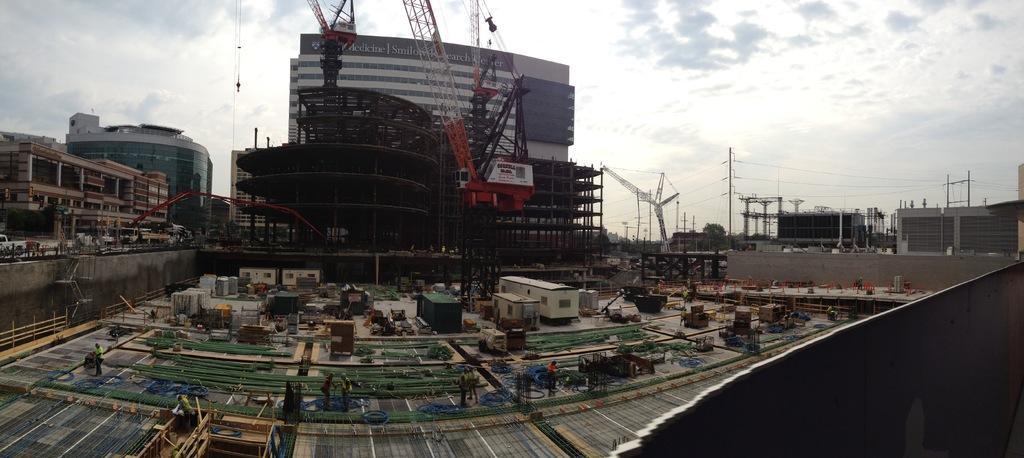Could you give a brief overview of what you see in this image? In the center of the image there are buildings and we can see a crane. At the bottom there are people doing construction work and we can see blocks and sheds. In the background there are poles, wires and sky. 